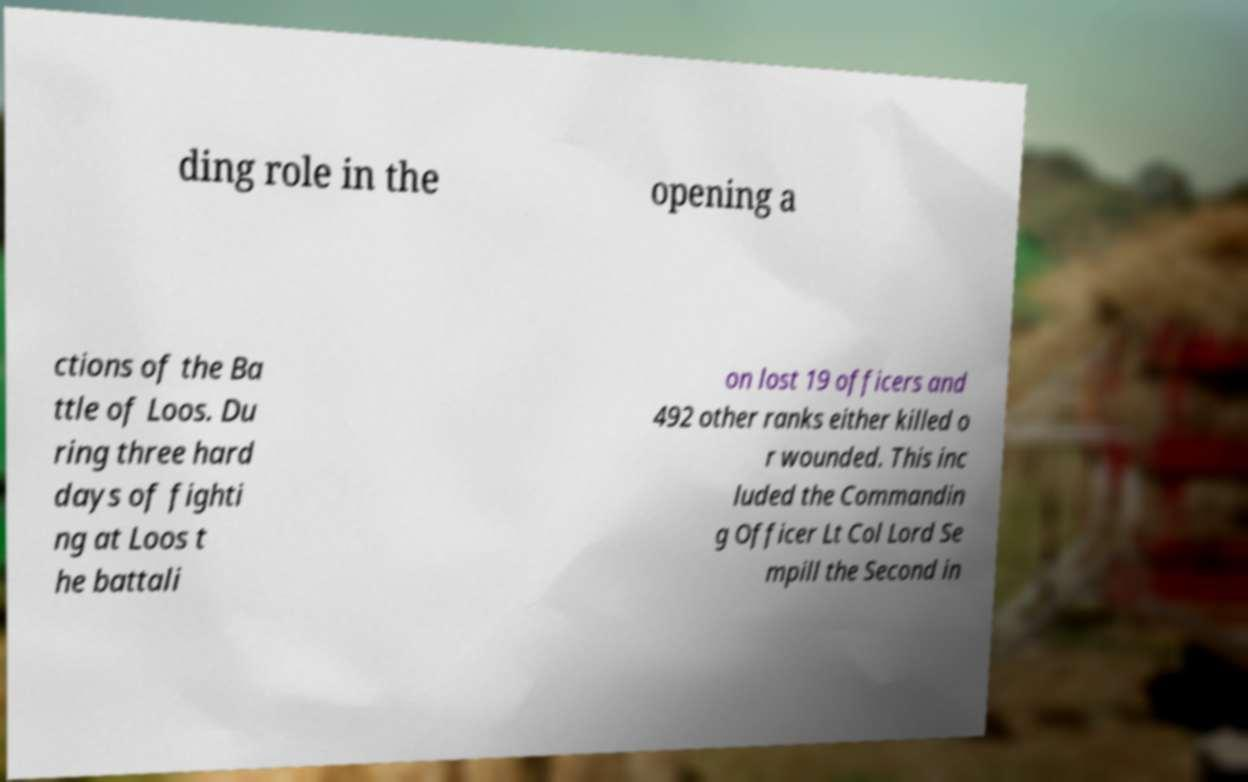Could you extract and type out the text from this image? ding role in the opening a ctions of the Ba ttle of Loos. Du ring three hard days of fighti ng at Loos t he battali on lost 19 officers and 492 other ranks either killed o r wounded. This inc luded the Commandin g Officer Lt Col Lord Se mpill the Second in 